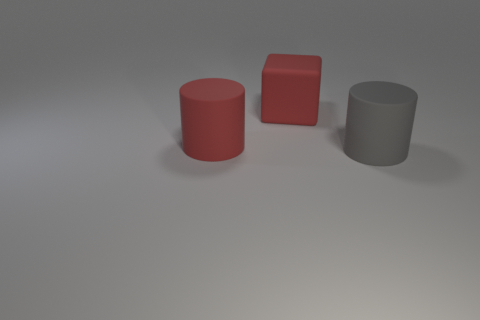Add 1 large yellow cylinders. How many objects exist? 4 Subtract all red rubber cylinders. Subtract all large red cylinders. How many objects are left? 1 Add 2 large red cylinders. How many large red cylinders are left? 3 Add 3 gray cylinders. How many gray cylinders exist? 4 Subtract 0 blue cylinders. How many objects are left? 3 Subtract all blocks. How many objects are left? 2 